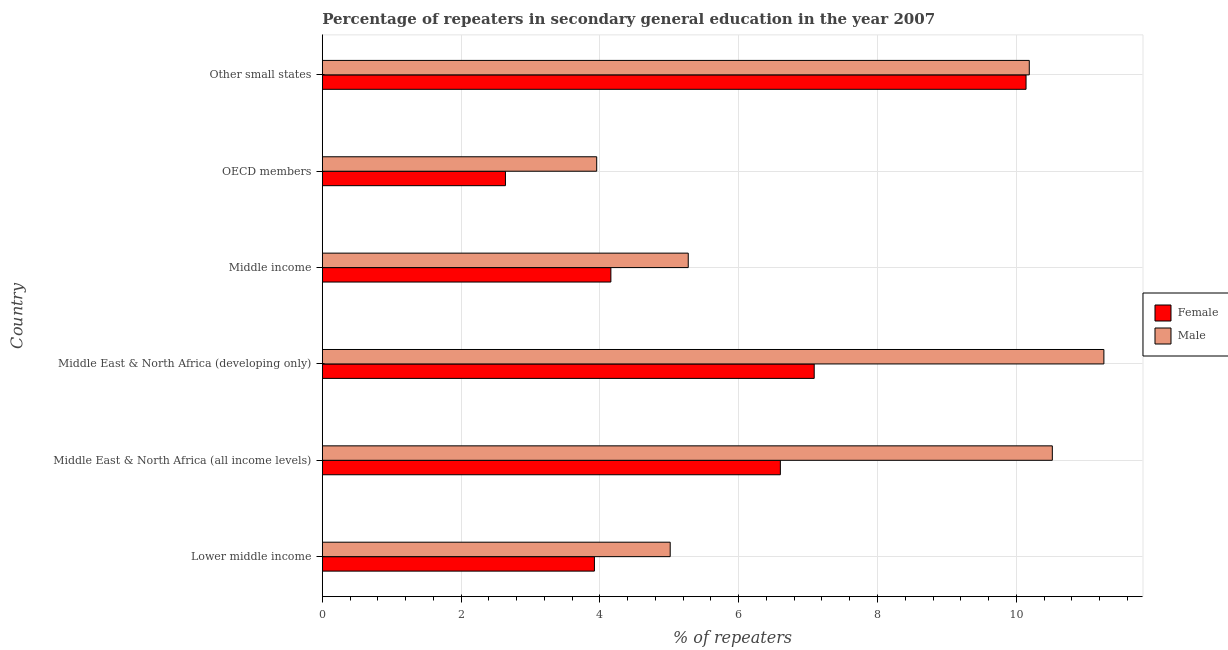Are the number of bars per tick equal to the number of legend labels?
Provide a short and direct response. Yes. Are the number of bars on each tick of the Y-axis equal?
Your answer should be very brief. Yes. How many bars are there on the 1st tick from the top?
Your answer should be very brief. 2. How many bars are there on the 5th tick from the bottom?
Offer a very short reply. 2. What is the label of the 5th group of bars from the top?
Make the answer very short. Middle East & North Africa (all income levels). In how many cases, is the number of bars for a given country not equal to the number of legend labels?
Provide a succinct answer. 0. What is the percentage of male repeaters in OECD members?
Provide a short and direct response. 3.95. Across all countries, what is the maximum percentage of female repeaters?
Offer a very short reply. 10.14. Across all countries, what is the minimum percentage of female repeaters?
Keep it short and to the point. 2.64. In which country was the percentage of male repeaters maximum?
Provide a succinct answer. Middle East & North Africa (developing only). What is the total percentage of male repeaters in the graph?
Offer a terse response. 46.21. What is the difference between the percentage of male repeaters in Middle East & North Africa (developing only) and that in Middle income?
Provide a succinct answer. 5.99. What is the difference between the percentage of female repeaters in OECD members and the percentage of male repeaters in Other small states?
Your response must be concise. -7.55. What is the average percentage of male repeaters per country?
Ensure brevity in your answer.  7.7. What is the difference between the percentage of female repeaters and percentage of male repeaters in Middle income?
Provide a short and direct response. -1.11. In how many countries, is the percentage of female repeaters greater than 0.8 %?
Your answer should be compact. 6. What is the ratio of the percentage of female repeaters in Middle East & North Africa (all income levels) to that in Middle East & North Africa (developing only)?
Your answer should be compact. 0.93. Is the difference between the percentage of female repeaters in OECD members and Other small states greater than the difference between the percentage of male repeaters in OECD members and Other small states?
Keep it short and to the point. No. What is the difference between the highest and the second highest percentage of female repeaters?
Ensure brevity in your answer.  3.05. What is the difference between the highest and the lowest percentage of female repeaters?
Keep it short and to the point. 7.5. In how many countries, is the percentage of female repeaters greater than the average percentage of female repeaters taken over all countries?
Offer a very short reply. 3. How many bars are there?
Give a very brief answer. 12. Are all the bars in the graph horizontal?
Your response must be concise. Yes. How many countries are there in the graph?
Ensure brevity in your answer.  6. Does the graph contain grids?
Ensure brevity in your answer.  Yes. Where does the legend appear in the graph?
Ensure brevity in your answer.  Center right. How many legend labels are there?
Provide a short and direct response. 2. What is the title of the graph?
Give a very brief answer. Percentage of repeaters in secondary general education in the year 2007. Does "Fixed telephone" appear as one of the legend labels in the graph?
Give a very brief answer. No. What is the label or title of the X-axis?
Offer a very short reply. % of repeaters. What is the % of repeaters in Female in Lower middle income?
Your answer should be compact. 3.92. What is the % of repeaters of Male in Lower middle income?
Your response must be concise. 5.01. What is the % of repeaters of Female in Middle East & North Africa (all income levels)?
Provide a succinct answer. 6.6. What is the % of repeaters in Male in Middle East & North Africa (all income levels)?
Your answer should be compact. 10.52. What is the % of repeaters of Female in Middle East & North Africa (developing only)?
Offer a terse response. 7.09. What is the % of repeaters of Male in Middle East & North Africa (developing only)?
Your answer should be compact. 11.26. What is the % of repeaters in Female in Middle income?
Offer a very short reply. 4.16. What is the % of repeaters in Male in Middle income?
Offer a very short reply. 5.27. What is the % of repeaters in Female in OECD members?
Provide a succinct answer. 2.64. What is the % of repeaters in Male in OECD members?
Your response must be concise. 3.95. What is the % of repeaters of Female in Other small states?
Make the answer very short. 10.14. What is the % of repeaters in Male in Other small states?
Make the answer very short. 10.19. Across all countries, what is the maximum % of repeaters of Female?
Ensure brevity in your answer.  10.14. Across all countries, what is the maximum % of repeaters in Male?
Your answer should be very brief. 11.26. Across all countries, what is the minimum % of repeaters of Female?
Keep it short and to the point. 2.64. Across all countries, what is the minimum % of repeaters of Male?
Give a very brief answer. 3.95. What is the total % of repeaters in Female in the graph?
Offer a terse response. 34.55. What is the total % of repeaters in Male in the graph?
Provide a short and direct response. 46.21. What is the difference between the % of repeaters in Female in Lower middle income and that in Middle East & North Africa (all income levels)?
Provide a succinct answer. -2.68. What is the difference between the % of repeaters in Male in Lower middle income and that in Middle East & North Africa (all income levels)?
Your response must be concise. -5.51. What is the difference between the % of repeaters in Female in Lower middle income and that in Middle East & North Africa (developing only)?
Ensure brevity in your answer.  -3.17. What is the difference between the % of repeaters in Male in Lower middle income and that in Middle East & North Africa (developing only)?
Ensure brevity in your answer.  -6.25. What is the difference between the % of repeaters in Female in Lower middle income and that in Middle income?
Your answer should be very brief. -0.24. What is the difference between the % of repeaters of Male in Lower middle income and that in Middle income?
Offer a very short reply. -0.26. What is the difference between the % of repeaters in Female in Lower middle income and that in OECD members?
Offer a terse response. 1.28. What is the difference between the % of repeaters in Male in Lower middle income and that in OECD members?
Keep it short and to the point. 1.06. What is the difference between the % of repeaters of Female in Lower middle income and that in Other small states?
Give a very brief answer. -6.22. What is the difference between the % of repeaters in Male in Lower middle income and that in Other small states?
Provide a succinct answer. -5.17. What is the difference between the % of repeaters in Female in Middle East & North Africa (all income levels) and that in Middle East & North Africa (developing only)?
Your answer should be very brief. -0.49. What is the difference between the % of repeaters of Male in Middle East & North Africa (all income levels) and that in Middle East & North Africa (developing only)?
Give a very brief answer. -0.74. What is the difference between the % of repeaters of Female in Middle East & North Africa (all income levels) and that in Middle income?
Provide a short and direct response. 2.44. What is the difference between the % of repeaters in Male in Middle East & North Africa (all income levels) and that in Middle income?
Provide a succinct answer. 5.25. What is the difference between the % of repeaters of Female in Middle East & North Africa (all income levels) and that in OECD members?
Your response must be concise. 3.96. What is the difference between the % of repeaters of Male in Middle East & North Africa (all income levels) and that in OECD members?
Provide a short and direct response. 6.57. What is the difference between the % of repeaters in Female in Middle East & North Africa (all income levels) and that in Other small states?
Make the answer very short. -3.54. What is the difference between the % of repeaters in Male in Middle East & North Africa (all income levels) and that in Other small states?
Offer a terse response. 0.33. What is the difference between the % of repeaters of Female in Middle East & North Africa (developing only) and that in Middle income?
Offer a terse response. 2.93. What is the difference between the % of repeaters in Male in Middle East & North Africa (developing only) and that in Middle income?
Provide a succinct answer. 5.99. What is the difference between the % of repeaters in Female in Middle East & North Africa (developing only) and that in OECD members?
Offer a very short reply. 4.45. What is the difference between the % of repeaters of Male in Middle East & North Africa (developing only) and that in OECD members?
Provide a short and direct response. 7.31. What is the difference between the % of repeaters of Female in Middle East & North Africa (developing only) and that in Other small states?
Your response must be concise. -3.05. What is the difference between the % of repeaters of Male in Middle East & North Africa (developing only) and that in Other small states?
Keep it short and to the point. 1.08. What is the difference between the % of repeaters in Female in Middle income and that in OECD members?
Offer a very short reply. 1.52. What is the difference between the % of repeaters of Male in Middle income and that in OECD members?
Offer a very short reply. 1.32. What is the difference between the % of repeaters of Female in Middle income and that in Other small states?
Make the answer very short. -5.98. What is the difference between the % of repeaters in Male in Middle income and that in Other small states?
Your response must be concise. -4.91. What is the difference between the % of repeaters of Female in OECD members and that in Other small states?
Your answer should be very brief. -7.5. What is the difference between the % of repeaters of Male in OECD members and that in Other small states?
Offer a very short reply. -6.23. What is the difference between the % of repeaters of Female in Lower middle income and the % of repeaters of Male in Middle East & North Africa (all income levels)?
Ensure brevity in your answer.  -6.6. What is the difference between the % of repeaters of Female in Lower middle income and the % of repeaters of Male in Middle East & North Africa (developing only)?
Keep it short and to the point. -7.34. What is the difference between the % of repeaters of Female in Lower middle income and the % of repeaters of Male in Middle income?
Make the answer very short. -1.35. What is the difference between the % of repeaters of Female in Lower middle income and the % of repeaters of Male in OECD members?
Your answer should be compact. -0.03. What is the difference between the % of repeaters of Female in Lower middle income and the % of repeaters of Male in Other small states?
Make the answer very short. -6.27. What is the difference between the % of repeaters in Female in Middle East & North Africa (all income levels) and the % of repeaters in Male in Middle East & North Africa (developing only)?
Your answer should be compact. -4.66. What is the difference between the % of repeaters in Female in Middle East & North Africa (all income levels) and the % of repeaters in Male in Middle income?
Provide a short and direct response. 1.33. What is the difference between the % of repeaters of Female in Middle East & North Africa (all income levels) and the % of repeaters of Male in OECD members?
Your answer should be compact. 2.65. What is the difference between the % of repeaters of Female in Middle East & North Africa (all income levels) and the % of repeaters of Male in Other small states?
Your response must be concise. -3.59. What is the difference between the % of repeaters of Female in Middle East & North Africa (developing only) and the % of repeaters of Male in Middle income?
Provide a succinct answer. 1.82. What is the difference between the % of repeaters in Female in Middle East & North Africa (developing only) and the % of repeaters in Male in OECD members?
Offer a terse response. 3.13. What is the difference between the % of repeaters in Female in Middle East & North Africa (developing only) and the % of repeaters in Male in Other small states?
Your response must be concise. -3.1. What is the difference between the % of repeaters of Female in Middle income and the % of repeaters of Male in OECD members?
Offer a very short reply. 0.2. What is the difference between the % of repeaters of Female in Middle income and the % of repeaters of Male in Other small states?
Your answer should be very brief. -6.03. What is the difference between the % of repeaters in Female in OECD members and the % of repeaters in Male in Other small states?
Provide a short and direct response. -7.55. What is the average % of repeaters of Female per country?
Your answer should be very brief. 5.76. What is the average % of repeaters in Male per country?
Make the answer very short. 7.7. What is the difference between the % of repeaters in Female and % of repeaters in Male in Lower middle income?
Keep it short and to the point. -1.09. What is the difference between the % of repeaters of Female and % of repeaters of Male in Middle East & North Africa (all income levels)?
Offer a very short reply. -3.92. What is the difference between the % of repeaters of Female and % of repeaters of Male in Middle East & North Africa (developing only)?
Your answer should be very brief. -4.17. What is the difference between the % of repeaters in Female and % of repeaters in Male in Middle income?
Your answer should be very brief. -1.11. What is the difference between the % of repeaters of Female and % of repeaters of Male in OECD members?
Your response must be concise. -1.31. What is the difference between the % of repeaters in Female and % of repeaters in Male in Other small states?
Ensure brevity in your answer.  -0.05. What is the ratio of the % of repeaters in Female in Lower middle income to that in Middle East & North Africa (all income levels)?
Offer a terse response. 0.59. What is the ratio of the % of repeaters in Male in Lower middle income to that in Middle East & North Africa (all income levels)?
Give a very brief answer. 0.48. What is the ratio of the % of repeaters in Female in Lower middle income to that in Middle East & North Africa (developing only)?
Provide a succinct answer. 0.55. What is the ratio of the % of repeaters in Male in Lower middle income to that in Middle East & North Africa (developing only)?
Keep it short and to the point. 0.45. What is the ratio of the % of repeaters of Female in Lower middle income to that in Middle income?
Your response must be concise. 0.94. What is the ratio of the % of repeaters in Male in Lower middle income to that in Middle income?
Your answer should be very brief. 0.95. What is the ratio of the % of repeaters of Female in Lower middle income to that in OECD members?
Provide a succinct answer. 1.49. What is the ratio of the % of repeaters of Male in Lower middle income to that in OECD members?
Make the answer very short. 1.27. What is the ratio of the % of repeaters in Female in Lower middle income to that in Other small states?
Ensure brevity in your answer.  0.39. What is the ratio of the % of repeaters in Male in Lower middle income to that in Other small states?
Your response must be concise. 0.49. What is the ratio of the % of repeaters of Female in Middle East & North Africa (all income levels) to that in Middle East & North Africa (developing only)?
Keep it short and to the point. 0.93. What is the ratio of the % of repeaters in Male in Middle East & North Africa (all income levels) to that in Middle East & North Africa (developing only)?
Offer a terse response. 0.93. What is the ratio of the % of repeaters in Female in Middle East & North Africa (all income levels) to that in Middle income?
Give a very brief answer. 1.59. What is the ratio of the % of repeaters in Male in Middle East & North Africa (all income levels) to that in Middle income?
Keep it short and to the point. 2. What is the ratio of the % of repeaters in Female in Middle East & North Africa (all income levels) to that in OECD members?
Provide a succinct answer. 2.5. What is the ratio of the % of repeaters in Male in Middle East & North Africa (all income levels) to that in OECD members?
Offer a terse response. 2.66. What is the ratio of the % of repeaters of Female in Middle East & North Africa (all income levels) to that in Other small states?
Provide a succinct answer. 0.65. What is the ratio of the % of repeaters in Male in Middle East & North Africa (all income levels) to that in Other small states?
Offer a terse response. 1.03. What is the ratio of the % of repeaters of Female in Middle East & North Africa (developing only) to that in Middle income?
Provide a short and direct response. 1.7. What is the ratio of the % of repeaters of Male in Middle East & North Africa (developing only) to that in Middle income?
Offer a very short reply. 2.14. What is the ratio of the % of repeaters of Female in Middle East & North Africa (developing only) to that in OECD members?
Ensure brevity in your answer.  2.69. What is the ratio of the % of repeaters in Male in Middle East & North Africa (developing only) to that in OECD members?
Keep it short and to the point. 2.85. What is the ratio of the % of repeaters in Female in Middle East & North Africa (developing only) to that in Other small states?
Offer a very short reply. 0.7. What is the ratio of the % of repeaters in Male in Middle East & North Africa (developing only) to that in Other small states?
Give a very brief answer. 1.11. What is the ratio of the % of repeaters of Female in Middle income to that in OECD members?
Ensure brevity in your answer.  1.58. What is the ratio of the % of repeaters in Male in Middle income to that in OECD members?
Your answer should be compact. 1.33. What is the ratio of the % of repeaters of Female in Middle income to that in Other small states?
Keep it short and to the point. 0.41. What is the ratio of the % of repeaters in Male in Middle income to that in Other small states?
Keep it short and to the point. 0.52. What is the ratio of the % of repeaters in Female in OECD members to that in Other small states?
Offer a terse response. 0.26. What is the ratio of the % of repeaters in Male in OECD members to that in Other small states?
Ensure brevity in your answer.  0.39. What is the difference between the highest and the second highest % of repeaters of Female?
Offer a terse response. 3.05. What is the difference between the highest and the second highest % of repeaters in Male?
Your answer should be very brief. 0.74. What is the difference between the highest and the lowest % of repeaters in Female?
Keep it short and to the point. 7.5. What is the difference between the highest and the lowest % of repeaters of Male?
Provide a succinct answer. 7.31. 